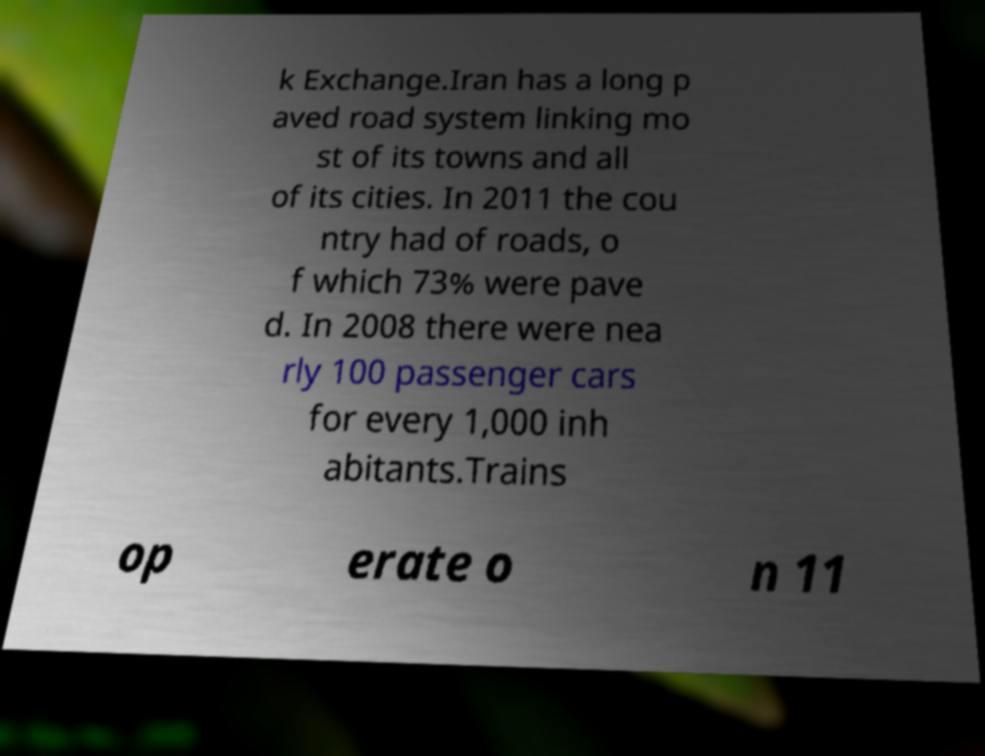Could you extract and type out the text from this image? k Exchange.Iran has a long p aved road system linking mo st of its towns and all of its cities. In 2011 the cou ntry had of roads, o f which 73% were pave d. In 2008 there were nea rly 100 passenger cars for every 1,000 inh abitants.Trains op erate o n 11 